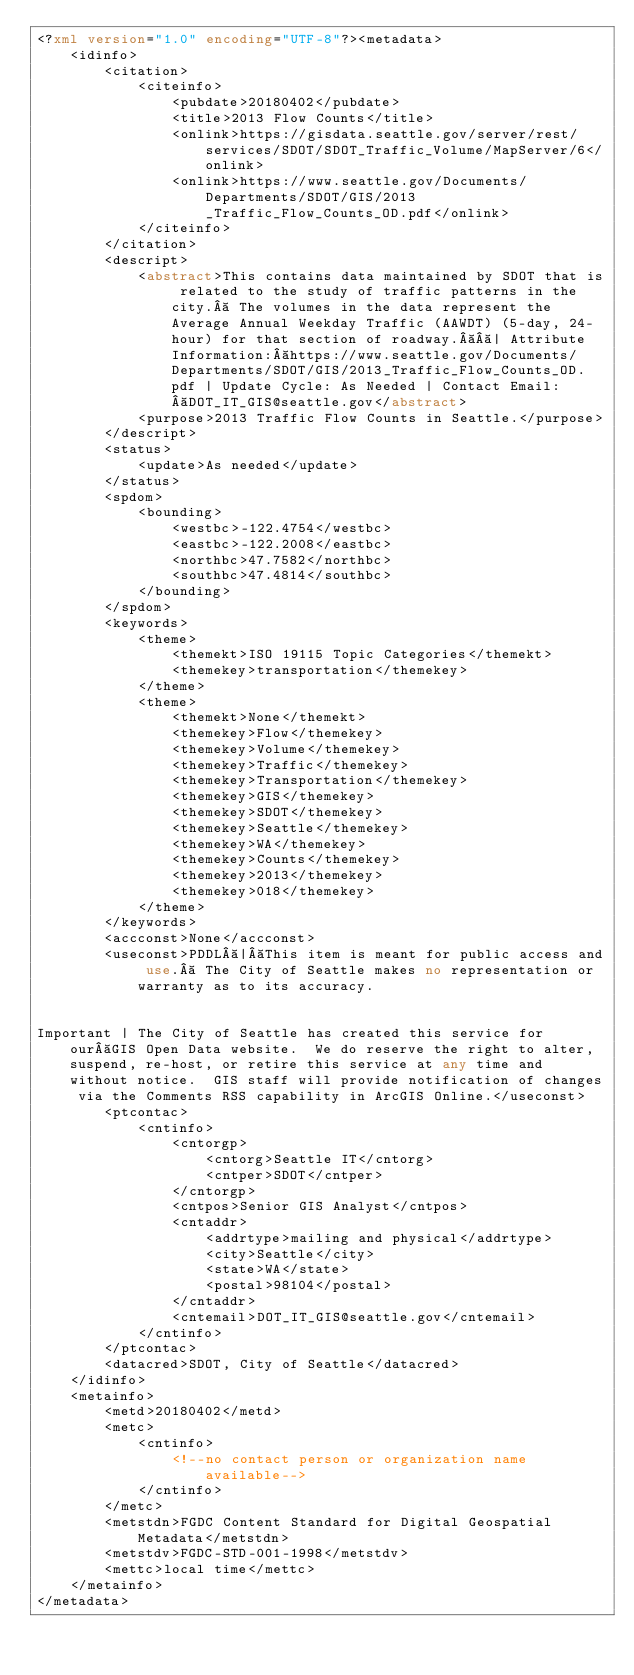<code> <loc_0><loc_0><loc_500><loc_500><_XML_><?xml version="1.0" encoding="UTF-8"?><metadata>
    <idinfo>
        <citation>
            <citeinfo>
                <pubdate>20180402</pubdate>
                <title>2013 Flow Counts</title>
                <onlink>https://gisdata.seattle.gov/server/rest/services/SDOT/SDOT_Traffic_Volume/MapServer/6</onlink>
                <onlink>https://www.seattle.gov/Documents/Departments/SDOT/GIS/2013_Traffic_Flow_Counts_OD.pdf</onlink>
            </citeinfo>
        </citation>
        <descript>
            <abstract>This contains data maintained by SDOT that is related to the study of traffic patterns in the city.  The volumes in the data represent the Average Annual Weekday Traffic (AAWDT) (5-day, 24-hour) for that section of roadway.  | Attribute Information: https://www.seattle.gov/Documents/Departments/SDOT/GIS/2013_Traffic_Flow_Counts_OD.pdf | Update Cycle: As Needed | Contact Email: DOT_IT_GIS@seattle.gov</abstract>
            <purpose>2013 Traffic Flow Counts in Seattle.</purpose>
        </descript>
        <status>
            <update>As needed</update>
        </status>
        <spdom>
            <bounding>
                <westbc>-122.4754</westbc>
                <eastbc>-122.2008</eastbc>
                <northbc>47.7582</northbc>
                <southbc>47.4814</southbc>
            </bounding>
        </spdom>
        <keywords>
            <theme>
                <themekt>ISO 19115 Topic Categories</themekt>
                <themekey>transportation</themekey>
            </theme>
            <theme>
                <themekt>None</themekt>
                <themekey>Flow</themekey>
                <themekey>Volume</themekey>
                <themekey>Traffic</themekey>
                <themekey>Transportation</themekey>
                <themekey>GIS</themekey>
                <themekey>SDOT</themekey>
                <themekey>Seattle</themekey>
                <themekey>WA</themekey>
                <themekey>Counts</themekey>
                <themekey>2013</themekey>
                <themekey>018</themekey>
            </theme>
        </keywords>
        <accconst>None</accconst>
        <useconst>PDDL | This item is meant for public access and use.  The City of Seattle makes no representation or warranty as to its accuracy.  


Important | The City of Seattle has created this service for our GIS Open Data website.  We do reserve the right to alter, suspend, re-host, or retire this service at any time and without notice.  GIS staff will provide notification of changes via the Comments RSS capability in ArcGIS Online.</useconst>
        <ptcontac>
            <cntinfo>
                <cntorgp>
                    <cntorg>Seattle IT</cntorg>
                    <cntper>SDOT</cntper>
                </cntorgp>
                <cntpos>Senior GIS Analyst</cntpos>
                <cntaddr>
                    <addrtype>mailing and physical</addrtype>
                    <city>Seattle</city>
                    <state>WA</state>
                    <postal>98104</postal>
                </cntaddr>
                <cntemail>DOT_IT_GIS@seattle.gov</cntemail>
            </cntinfo>
        </ptcontac>
        <datacred>SDOT, City of Seattle</datacred>
    </idinfo>
    <metainfo>
        <metd>20180402</metd>
        <metc>
            <cntinfo>
                <!--no contact person or organization name available-->
            </cntinfo>
        </metc>
        <metstdn>FGDC Content Standard for Digital Geospatial Metadata</metstdn>
        <metstdv>FGDC-STD-001-1998</metstdv>
        <mettc>local time</mettc>
    </metainfo>
</metadata>
</code> 